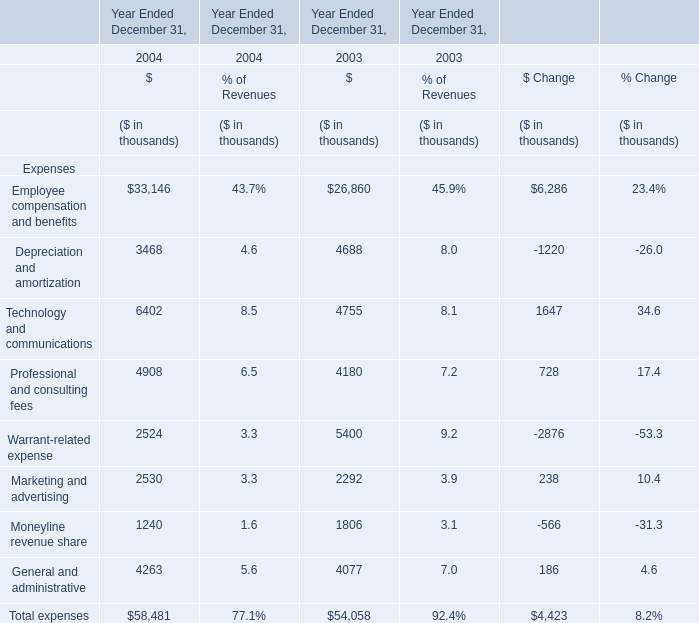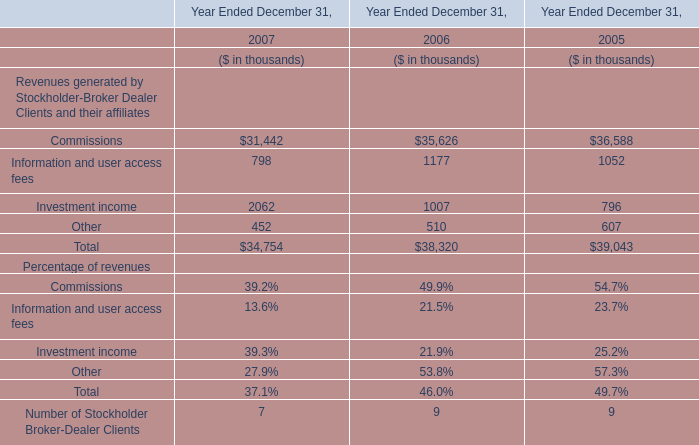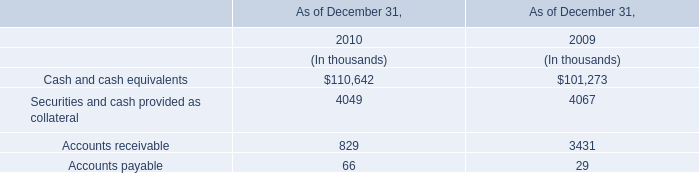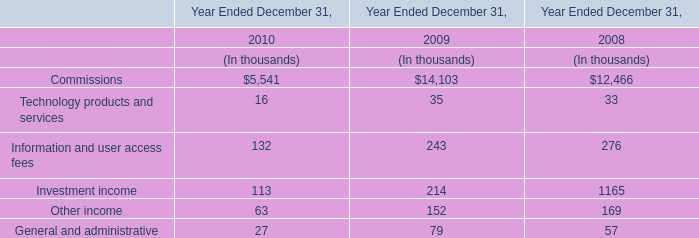If Technology and communications develops with the same growth rate in 2004, what will it reach in 2005? (in thousand) 
Computations: ((1 + ((6402 - 4755) / 4755)) * 6402)
Answer: 8619.47508. 